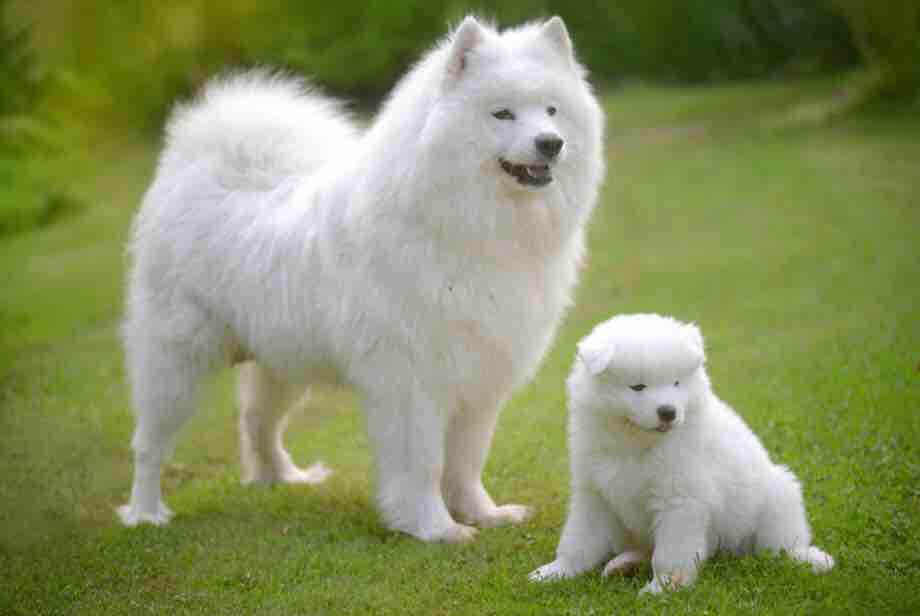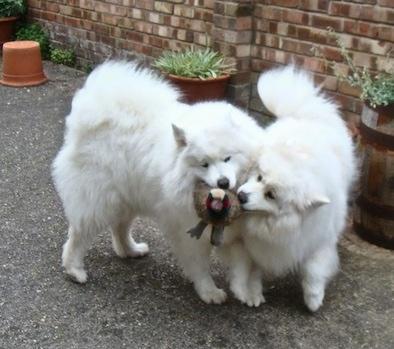The first image is the image on the left, the second image is the image on the right. Considering the images on both sides, is "There are exactly three dogs in total." valid? Answer yes or no. No. The first image is the image on the left, the second image is the image on the right. Considering the images on both sides, is "Two white dogs are playing with a toy." valid? Answer yes or no. Yes. 